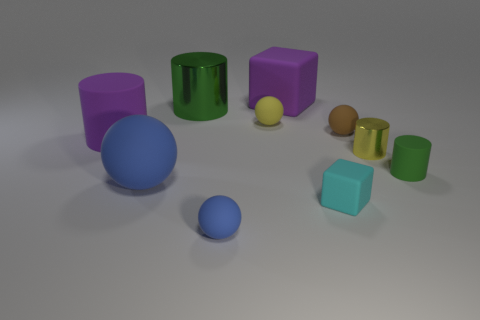Subtract all green cylinders. Subtract all small cyan matte things. How many objects are left? 7 Add 6 blue matte things. How many blue matte things are left? 8 Add 5 tiny cubes. How many tiny cubes exist? 6 Subtract 2 green cylinders. How many objects are left? 8 Subtract all cylinders. How many objects are left? 6 